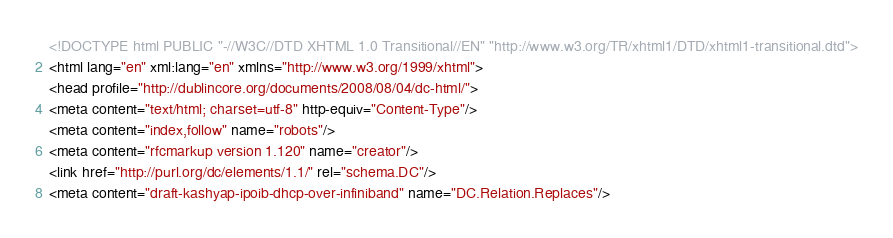Convert code to text. <code><loc_0><loc_0><loc_500><loc_500><_HTML_><!DOCTYPE html PUBLIC "-//W3C//DTD XHTML 1.0 Transitional//EN" "http://www.w3.org/TR/xhtml1/DTD/xhtml1-transitional.dtd">
<html lang="en" xml:lang="en" xmlns="http://www.w3.org/1999/xhtml">
<head profile="http://dublincore.org/documents/2008/08/04/dc-html/">
<meta content="text/html; charset=utf-8" http-equiv="Content-Type"/>
<meta content="index,follow" name="robots"/>
<meta content="rfcmarkup version 1.120" name="creator"/>
<link href="http://purl.org/dc/elements/1.1/" rel="schema.DC"/>
<meta content="draft-kashyap-ipoib-dhcp-over-infiniband" name="DC.Relation.Replaces"/></code> 